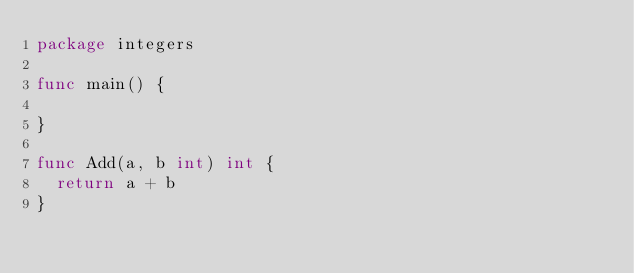Convert code to text. <code><loc_0><loc_0><loc_500><loc_500><_Go_>package integers

func main() {

}

func Add(a, b int) int {
	return a + b
}
</code> 